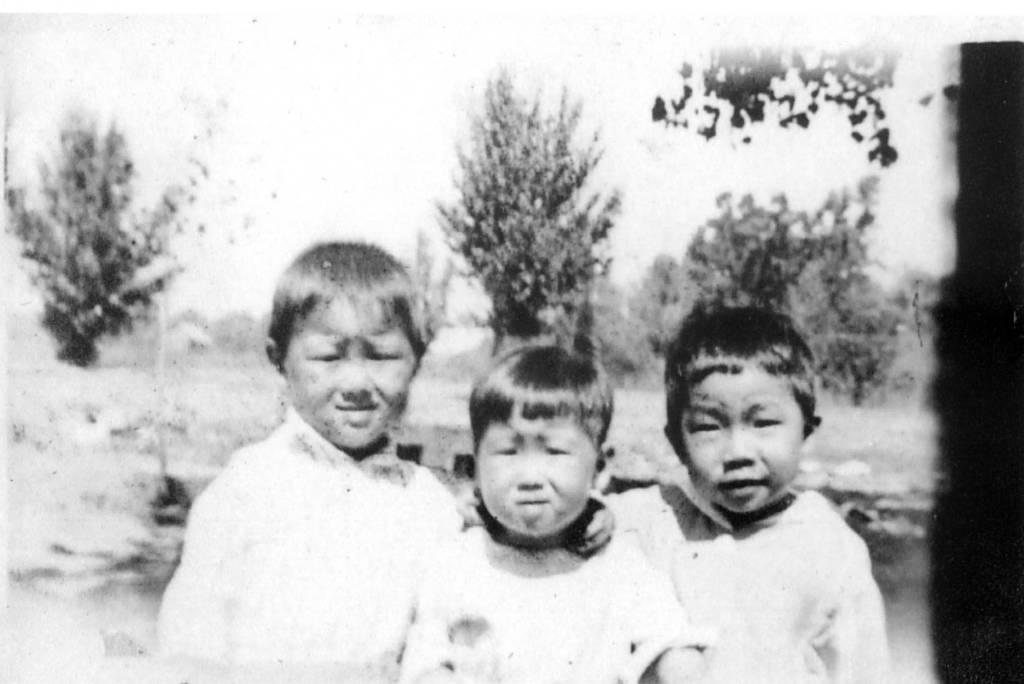How many people are in the image? There are three people in the image. What are the people wearing? The people are wearing white color dresses. What can be seen in the background of the image? There are trees in the background of the image. What is visible at the top of the image? The sky is visible at the top of the image. Is there any juice being served to the people in the image? There is no mention of juice or any beverage being served in the image. 